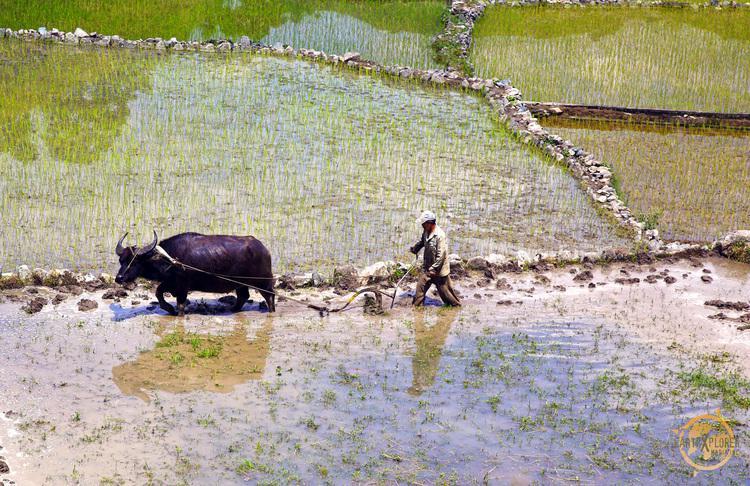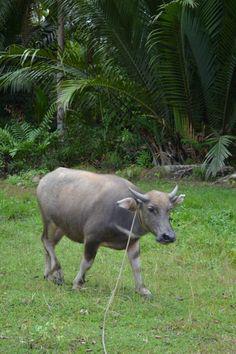The first image is the image on the left, the second image is the image on the right. Analyze the images presented: Is the assertion "One image features one horned animal standing in muddy water with its body turned leftward, and the other image features multiple hooved animals surrounded by greenery." valid? Answer yes or no. No. The first image is the image on the left, the second image is the image on the right. Analyze the images presented: Is the assertion "The cow in the image on the left is walking through the water." valid? Answer yes or no. Yes. 